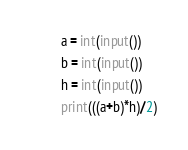<code> <loc_0><loc_0><loc_500><loc_500><_Python_>a = int(input())
b = int(input())
h = int(input())
print(((a+b)*h)/2)</code> 